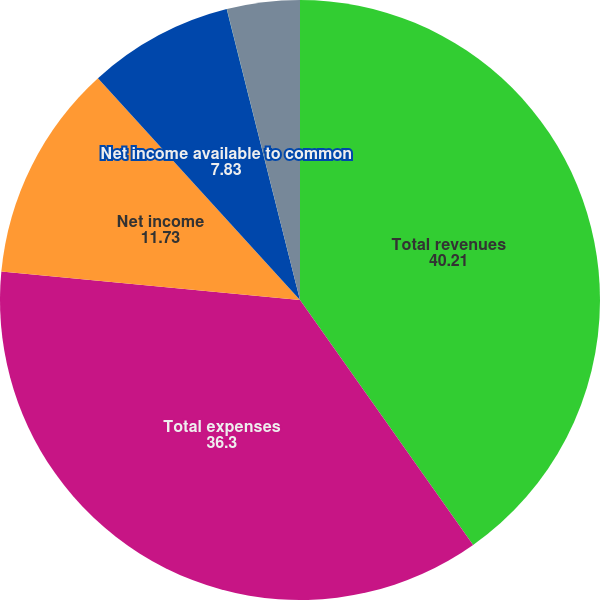<chart> <loc_0><loc_0><loc_500><loc_500><pie_chart><fcel>Total revenues<fcel>Total expenses<fcel>Net income<fcel>Net income available to common<fcel>Basic earnings per common<fcel>Diluted earnings per common<nl><fcel>40.21%<fcel>36.3%<fcel>11.73%<fcel>7.83%<fcel>0.01%<fcel>3.92%<nl></chart> 